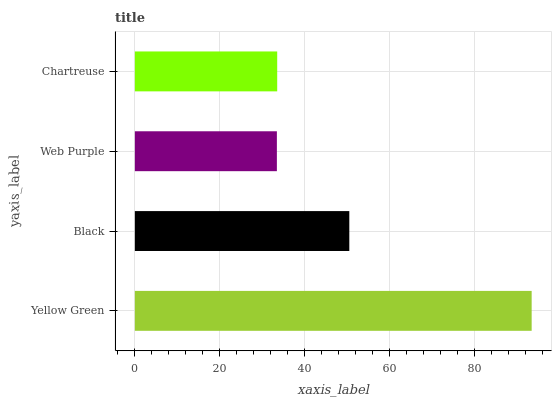Is Web Purple the minimum?
Answer yes or no. Yes. Is Yellow Green the maximum?
Answer yes or no. Yes. Is Black the minimum?
Answer yes or no. No. Is Black the maximum?
Answer yes or no. No. Is Yellow Green greater than Black?
Answer yes or no. Yes. Is Black less than Yellow Green?
Answer yes or no. Yes. Is Black greater than Yellow Green?
Answer yes or no. No. Is Yellow Green less than Black?
Answer yes or no. No. Is Black the high median?
Answer yes or no. Yes. Is Chartreuse the low median?
Answer yes or no. Yes. Is Yellow Green the high median?
Answer yes or no. No. Is Web Purple the low median?
Answer yes or no. No. 